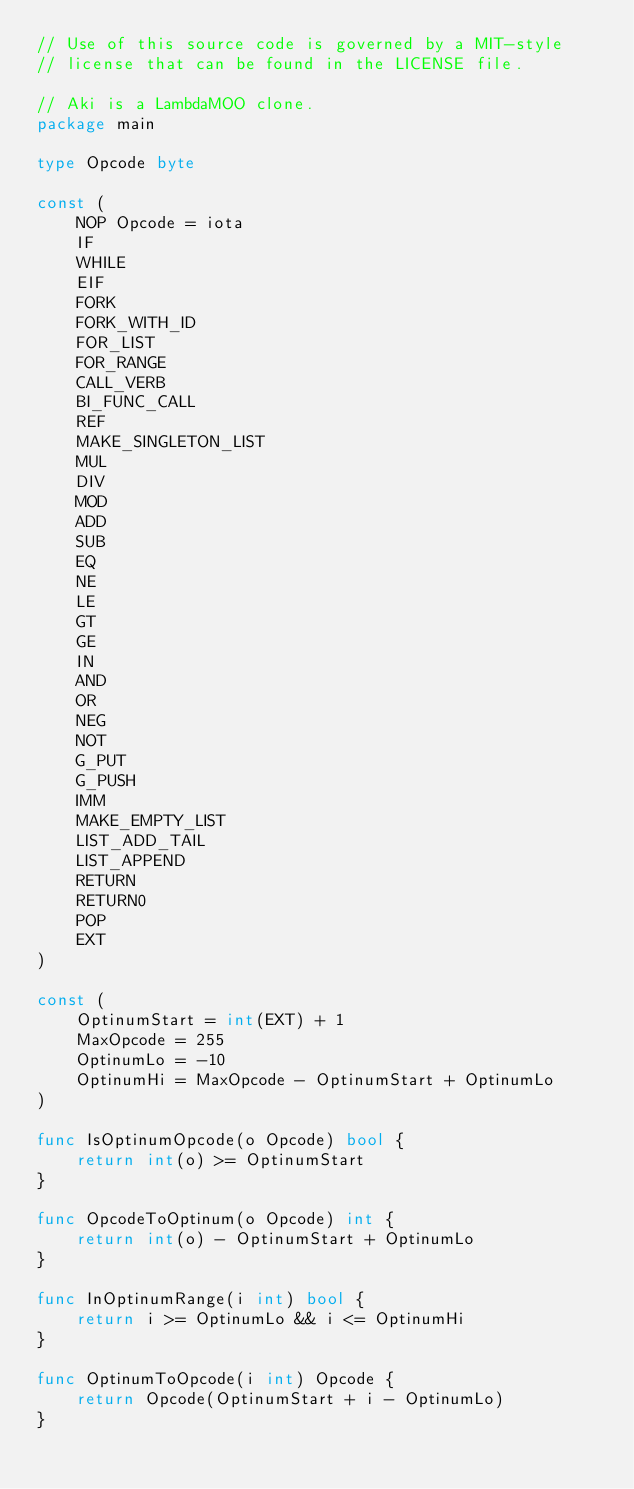<code> <loc_0><loc_0><loc_500><loc_500><_Go_>// Use of this source code is governed by a MIT-style
// license that can be found in the LICENSE file.

// Aki is a LambdaMOO clone.
package main

type Opcode byte

const (
    NOP Opcode = iota
    IF
    WHILE
    EIF
    FORK
    FORK_WITH_ID
    FOR_LIST
    FOR_RANGE
    CALL_VERB
    BI_FUNC_CALL
    REF
    MAKE_SINGLETON_LIST
    MUL
    DIV
    MOD
    ADD
    SUB
    EQ
    NE
    LE
    GT
    GE
    IN
    AND
    OR
    NEG
    NOT
    G_PUT
    G_PUSH
    IMM
    MAKE_EMPTY_LIST
    LIST_ADD_TAIL
    LIST_APPEND
    RETURN
    RETURN0
    POP
    EXT
)

const (
    OptinumStart = int(EXT) + 1
    MaxOpcode = 255
    OptinumLo = -10
    OptinumHi = MaxOpcode - OptinumStart + OptinumLo
)

func IsOptinumOpcode(o Opcode) bool {
    return int(o) >= OptinumStart
}

func OpcodeToOptinum(o Opcode) int {
    return int(o) - OptinumStart + OptinumLo
}

func InOptinumRange(i int) bool {
    return i >= OptinumLo && i <= OptinumHi
}

func OptinumToOpcode(i int) Opcode {
    return Opcode(OptinumStart + i - OptinumLo)
}

</code> 